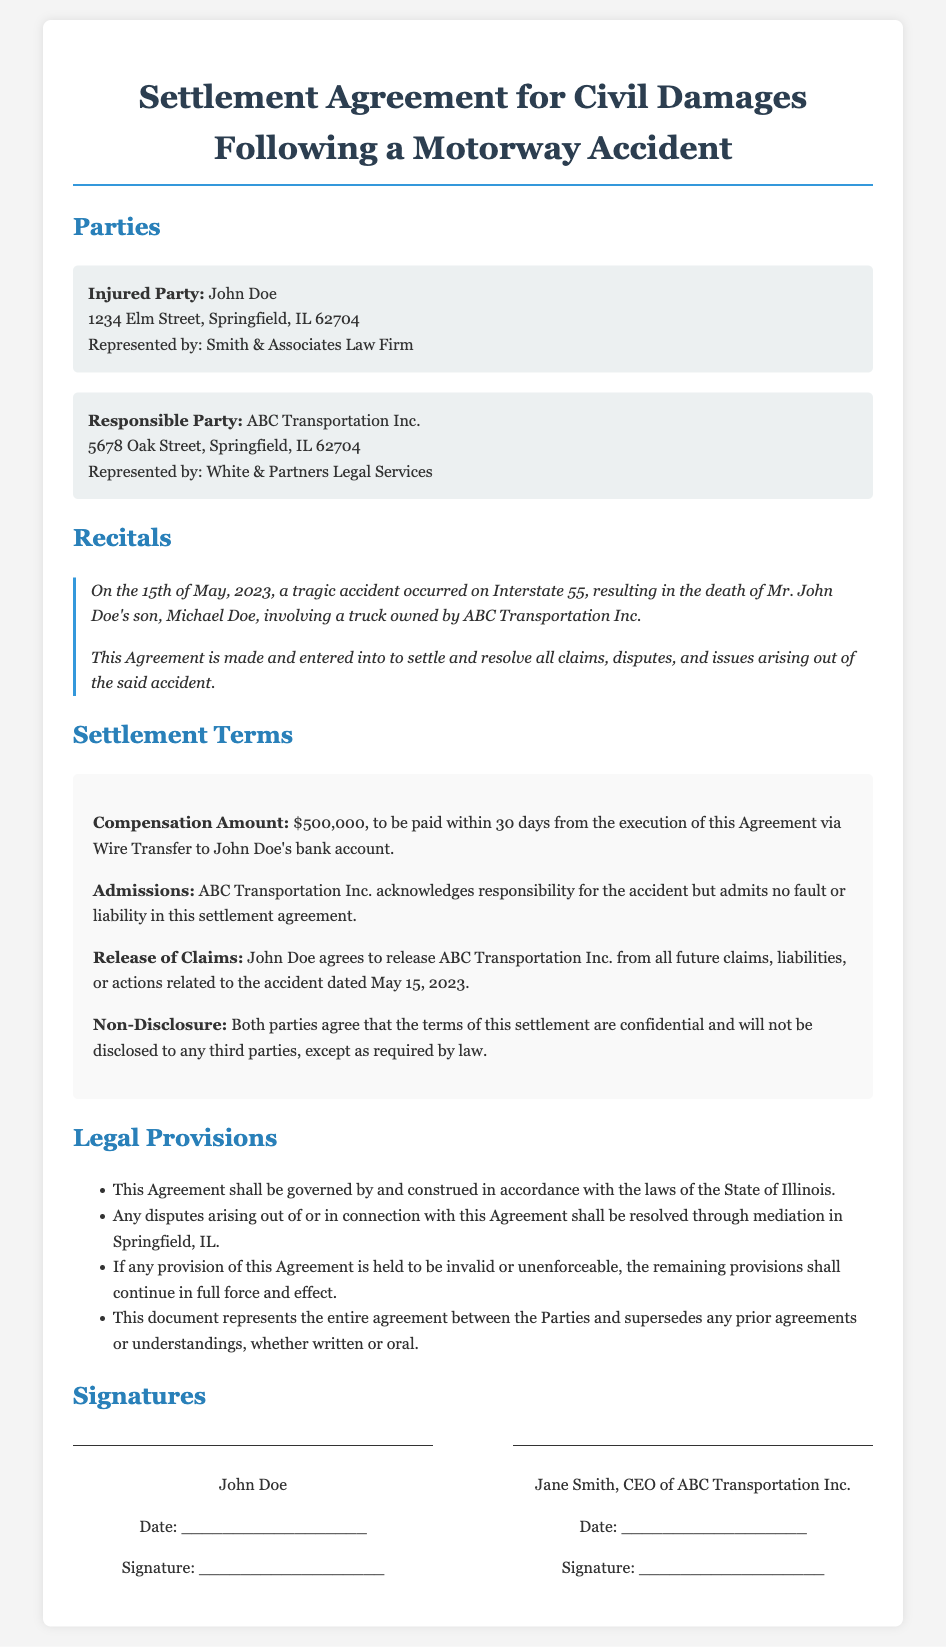What is the total compensation amount? The total compensation amount is explicitly stated in the document as $500,000, which is to be paid within a specified timeframe.
Answer: $500,000 Who is the Injured Party? The document identifies John Doe as the Injured Party, who is seeking compensation following the accident.
Answer: John Doe When did the accident occur? The document specifies the date of the accident as the 15th of May, 2023, which is critical information related to the case.
Answer: May 15, 2023 What is the governing law for this Agreement? The document states that the Agreement shall be governed by the laws of the State of Illinois, providing clarity on jurisdiction.
Answer: State of Illinois What is required before the payment is made? The document requires that the payment of the compensation amount be made within 30 days from the execution of the Agreement, indicating a specific deadline.
Answer: 30 days What does ABC Transportation Inc. admit in the Agreement? The document indicates that ABC Transportation Inc. acknowledges responsibility for the accident, providing an important context to the settlement.
Answer: Responsibility for the accident What is the purpose of this Settlement Agreement? The document states that the purpose is to settle and resolve all claims, disputes, and issues arising from the accident, clarifying the intent behind the Agreement.
Answer: Settle and resolve all claims Who represents the Responsible Party? The document specifies that White & Partners Legal Services represent ABC Transportation Inc., providing insight into the legal representation involved.
Answer: White & Partners Legal Services What must John Doe agree to regarding future claims? The document specifies that John Doe agrees to release ABC Transportation Inc. from all future claims related to the accident, outlining a key condition of the settlement.
Answer: Release from all future claims 